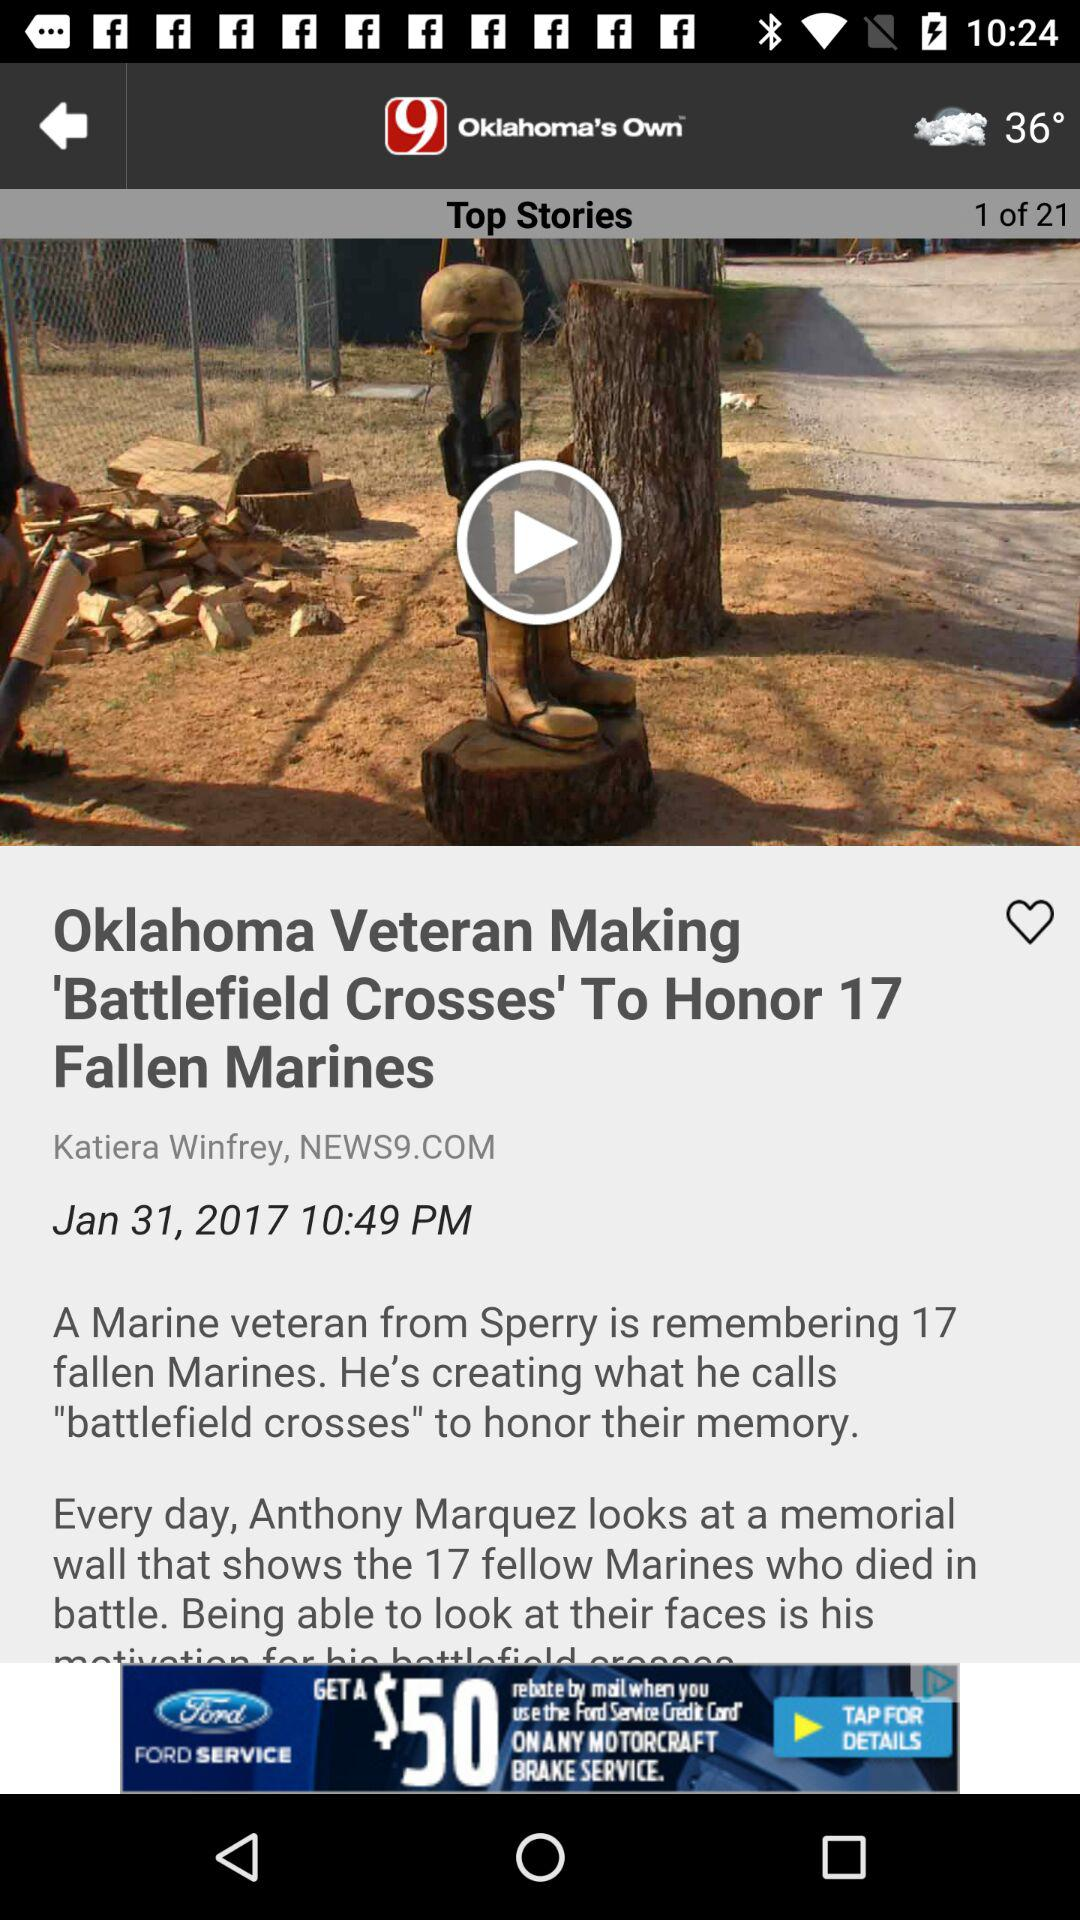How many Mariens died in battle? The Mariens that died in battle were 17. 